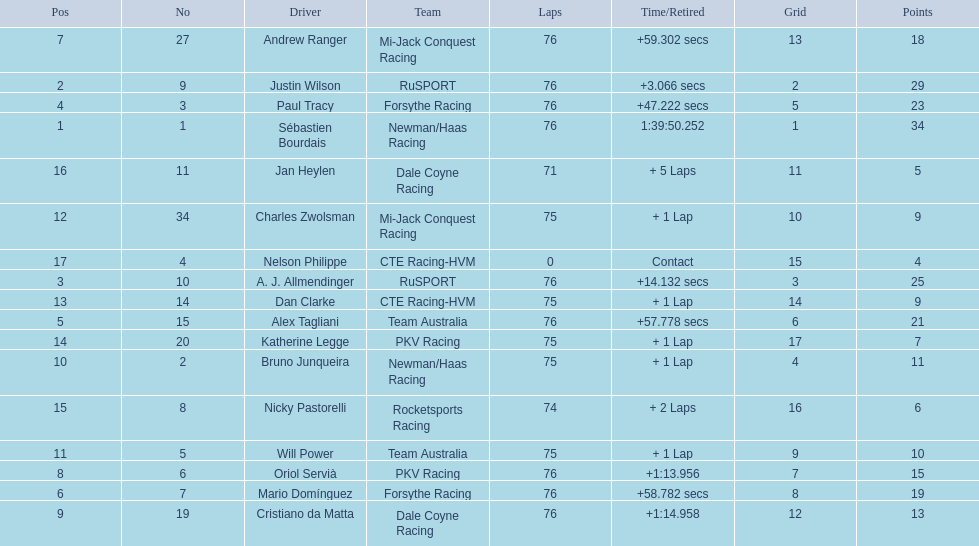What was alex taglini's final score in the tecate grand prix? 21. What was paul tracy's final score in the tecate grand prix? 23. Which driver finished first? Paul Tracy. 